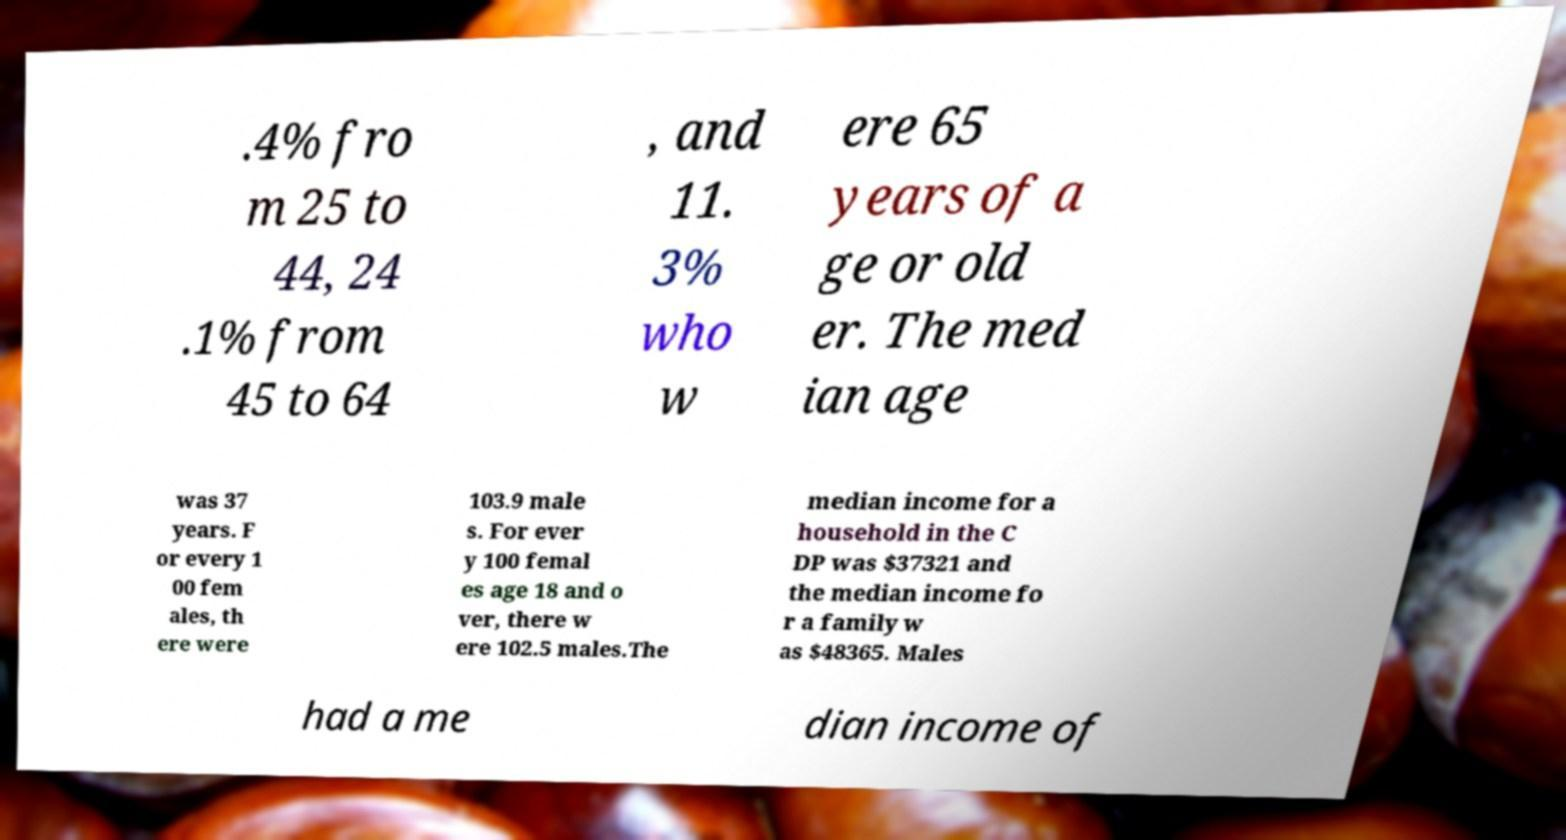For documentation purposes, I need the text within this image transcribed. Could you provide that? .4% fro m 25 to 44, 24 .1% from 45 to 64 , and 11. 3% who w ere 65 years of a ge or old er. The med ian age was 37 years. F or every 1 00 fem ales, th ere were 103.9 male s. For ever y 100 femal es age 18 and o ver, there w ere 102.5 males.The median income for a household in the C DP was $37321 and the median income fo r a family w as $48365. Males had a me dian income of 